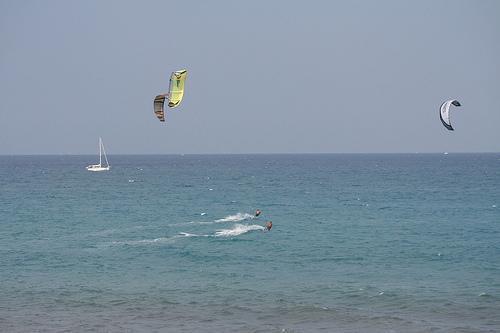How many parasailers do you see?
Give a very brief answer. 2. 